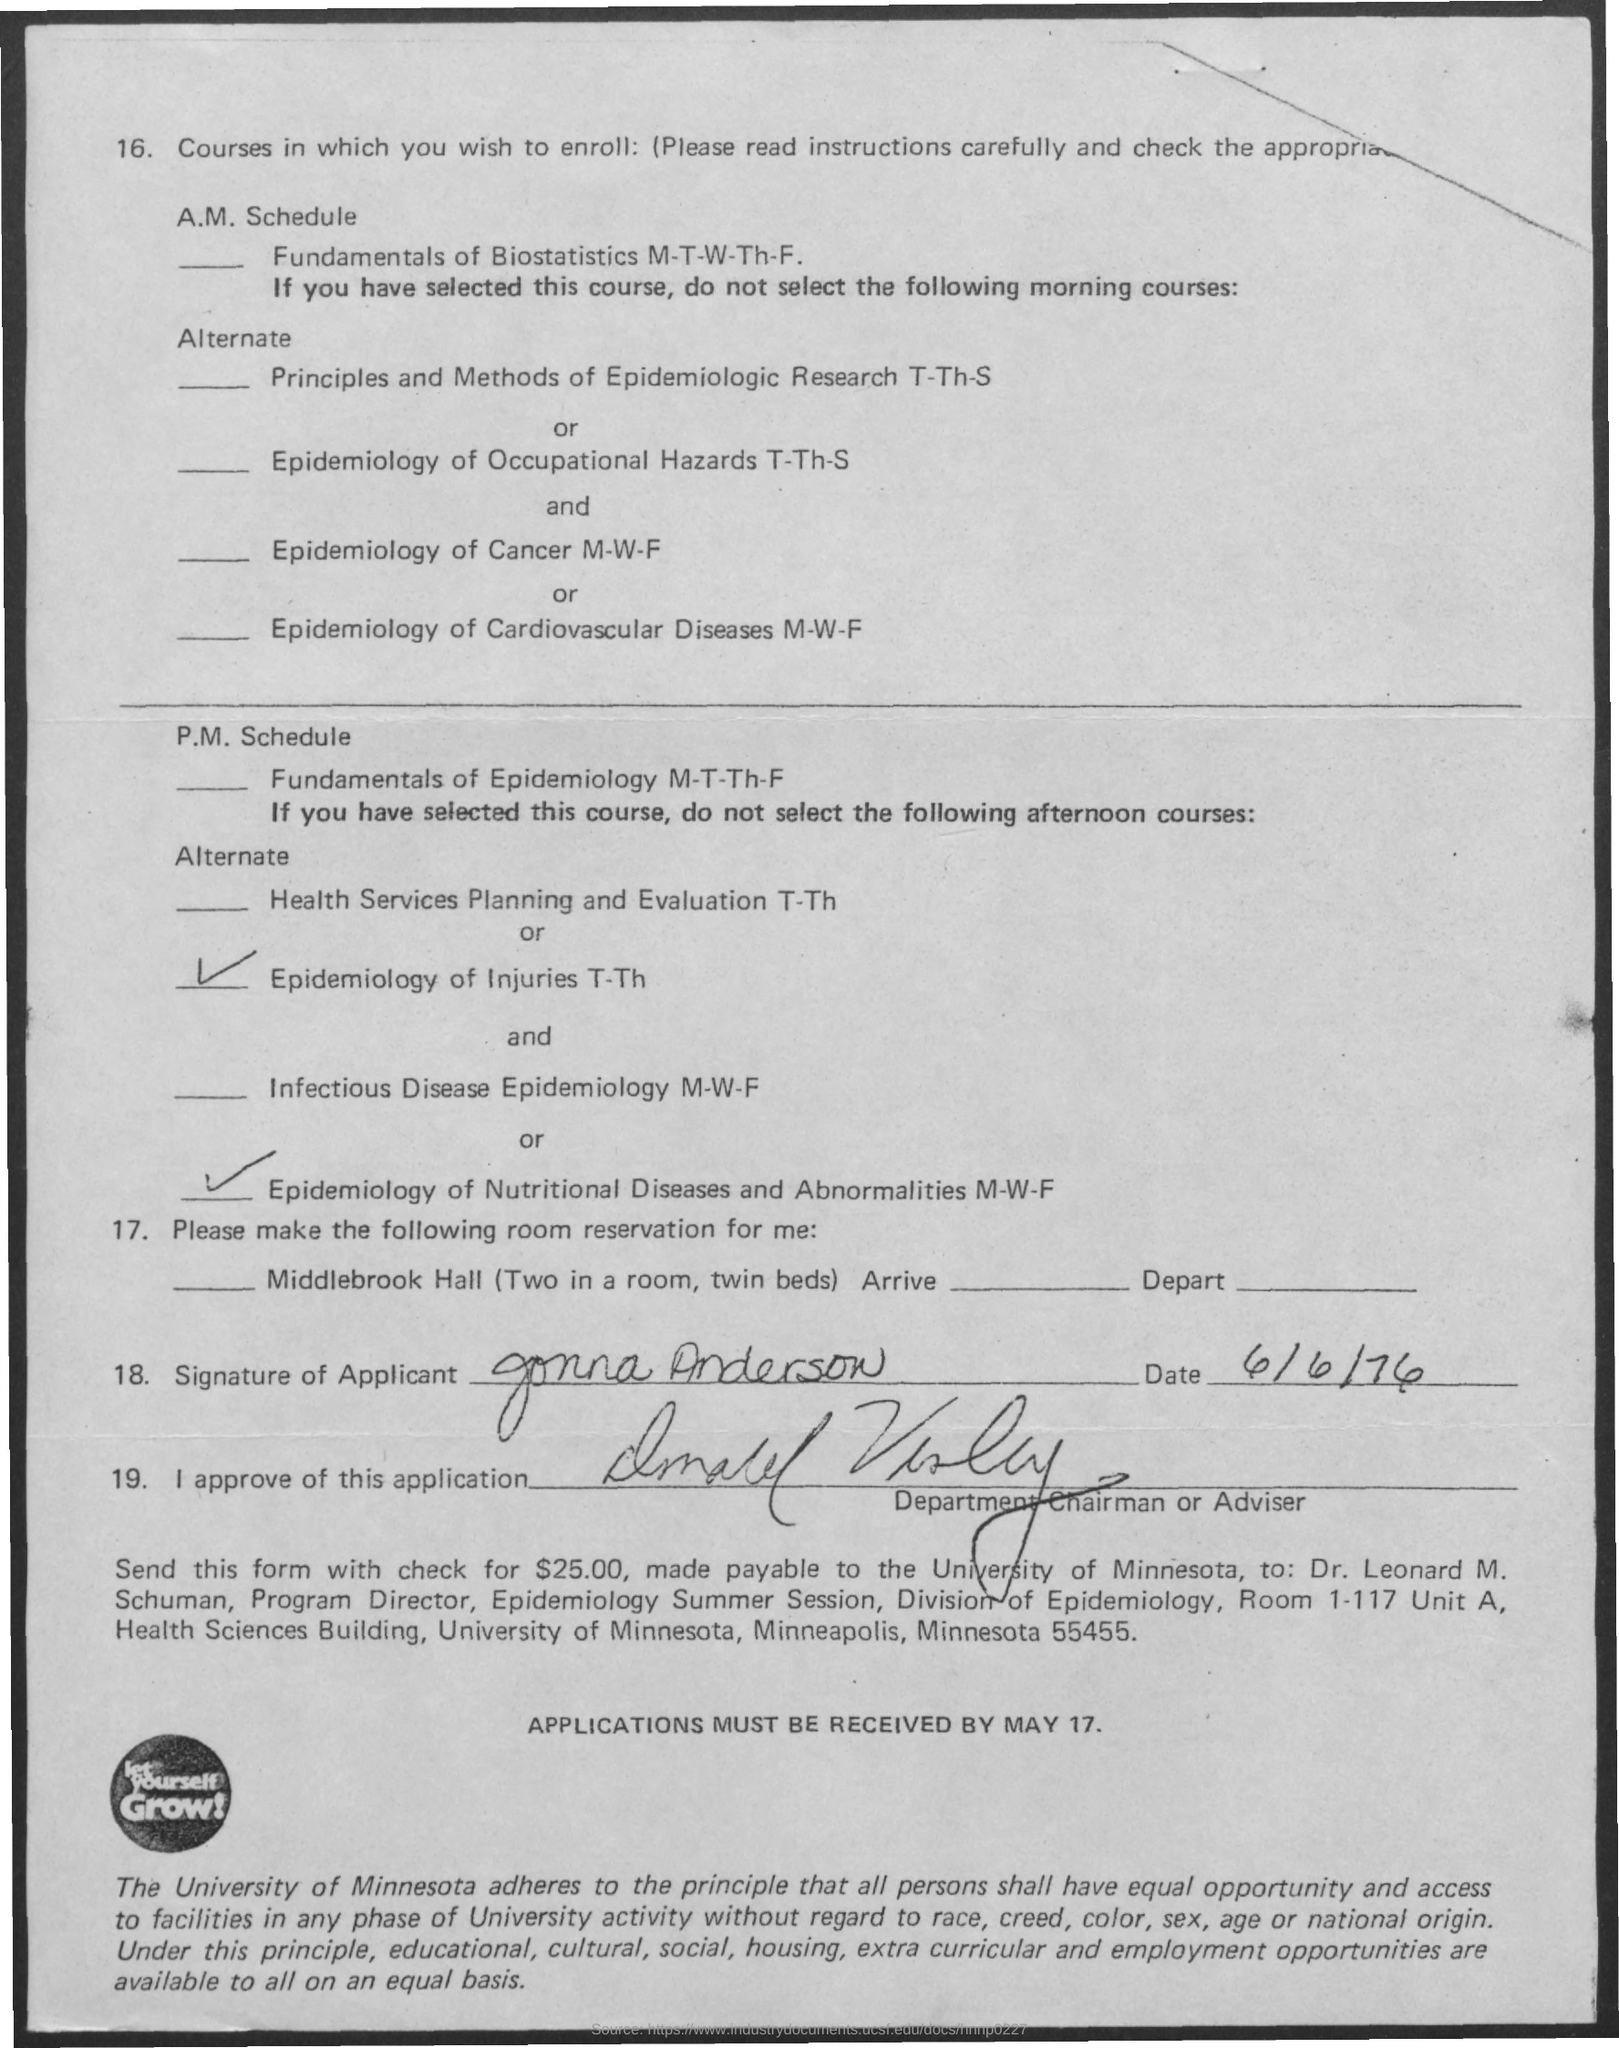What is the date on the document?
Make the answer very short. 6/6/76. 